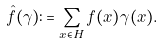<formula> <loc_0><loc_0><loc_500><loc_500>\hat { f } ( \gamma ) \colon = \sum _ { x \in H } f ( x ) \gamma ( x ) .</formula> 